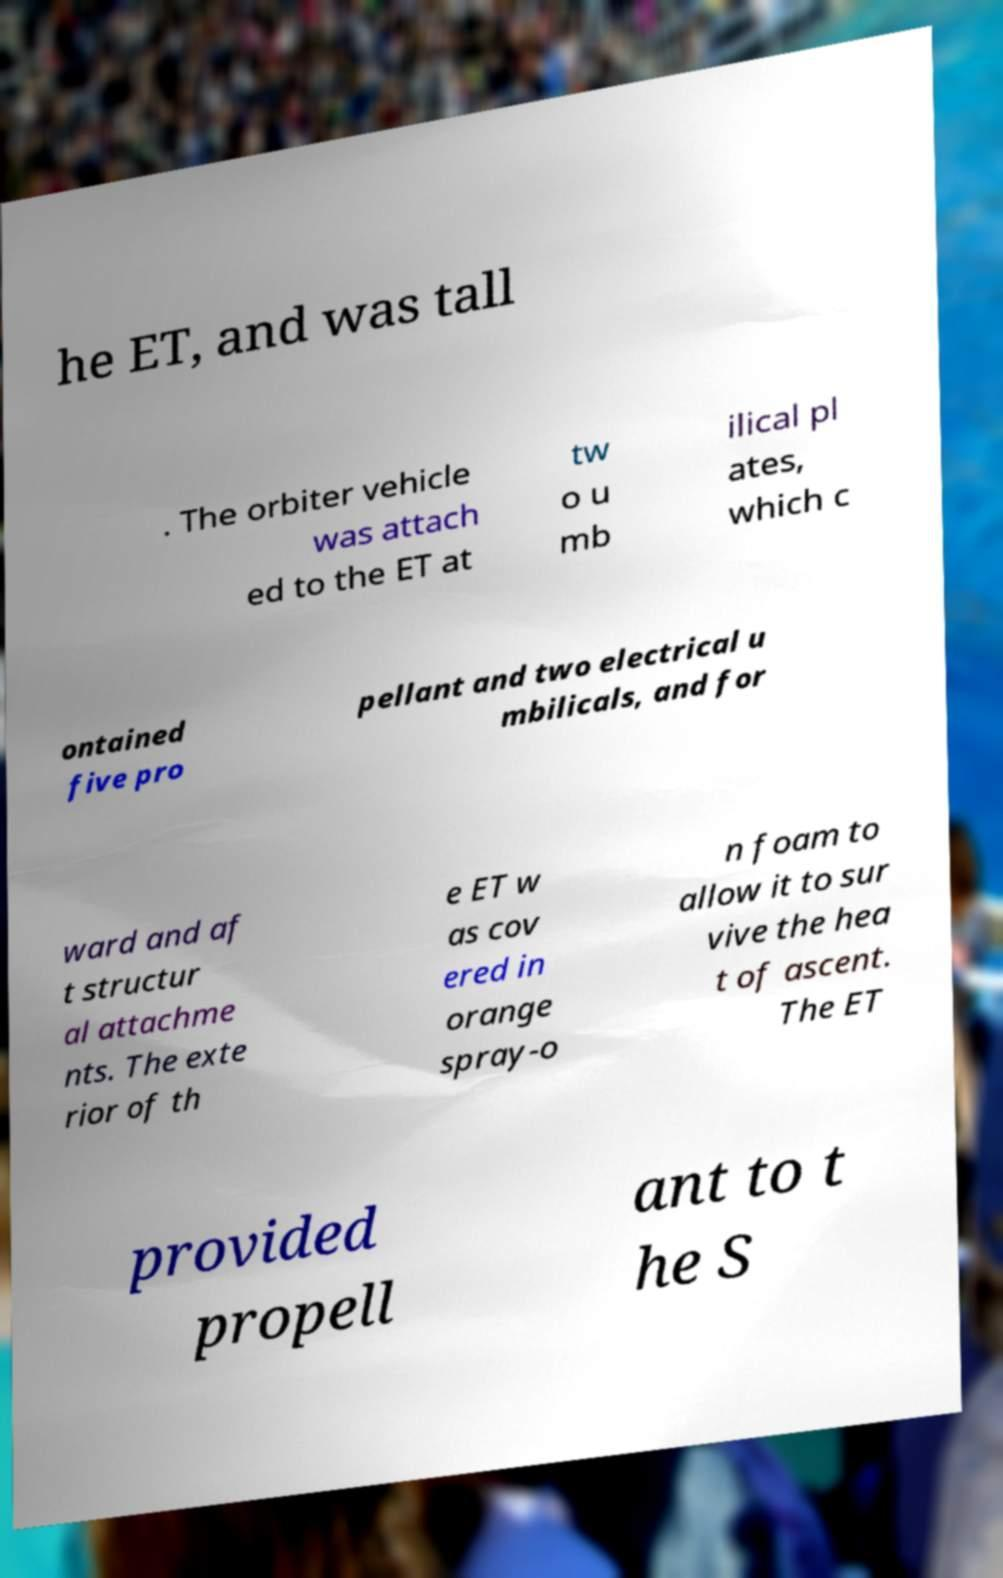For documentation purposes, I need the text within this image transcribed. Could you provide that? he ET, and was tall . The orbiter vehicle was attach ed to the ET at tw o u mb ilical pl ates, which c ontained five pro pellant and two electrical u mbilicals, and for ward and af t structur al attachme nts. The exte rior of th e ET w as cov ered in orange spray-o n foam to allow it to sur vive the hea t of ascent. The ET provided propell ant to t he S 